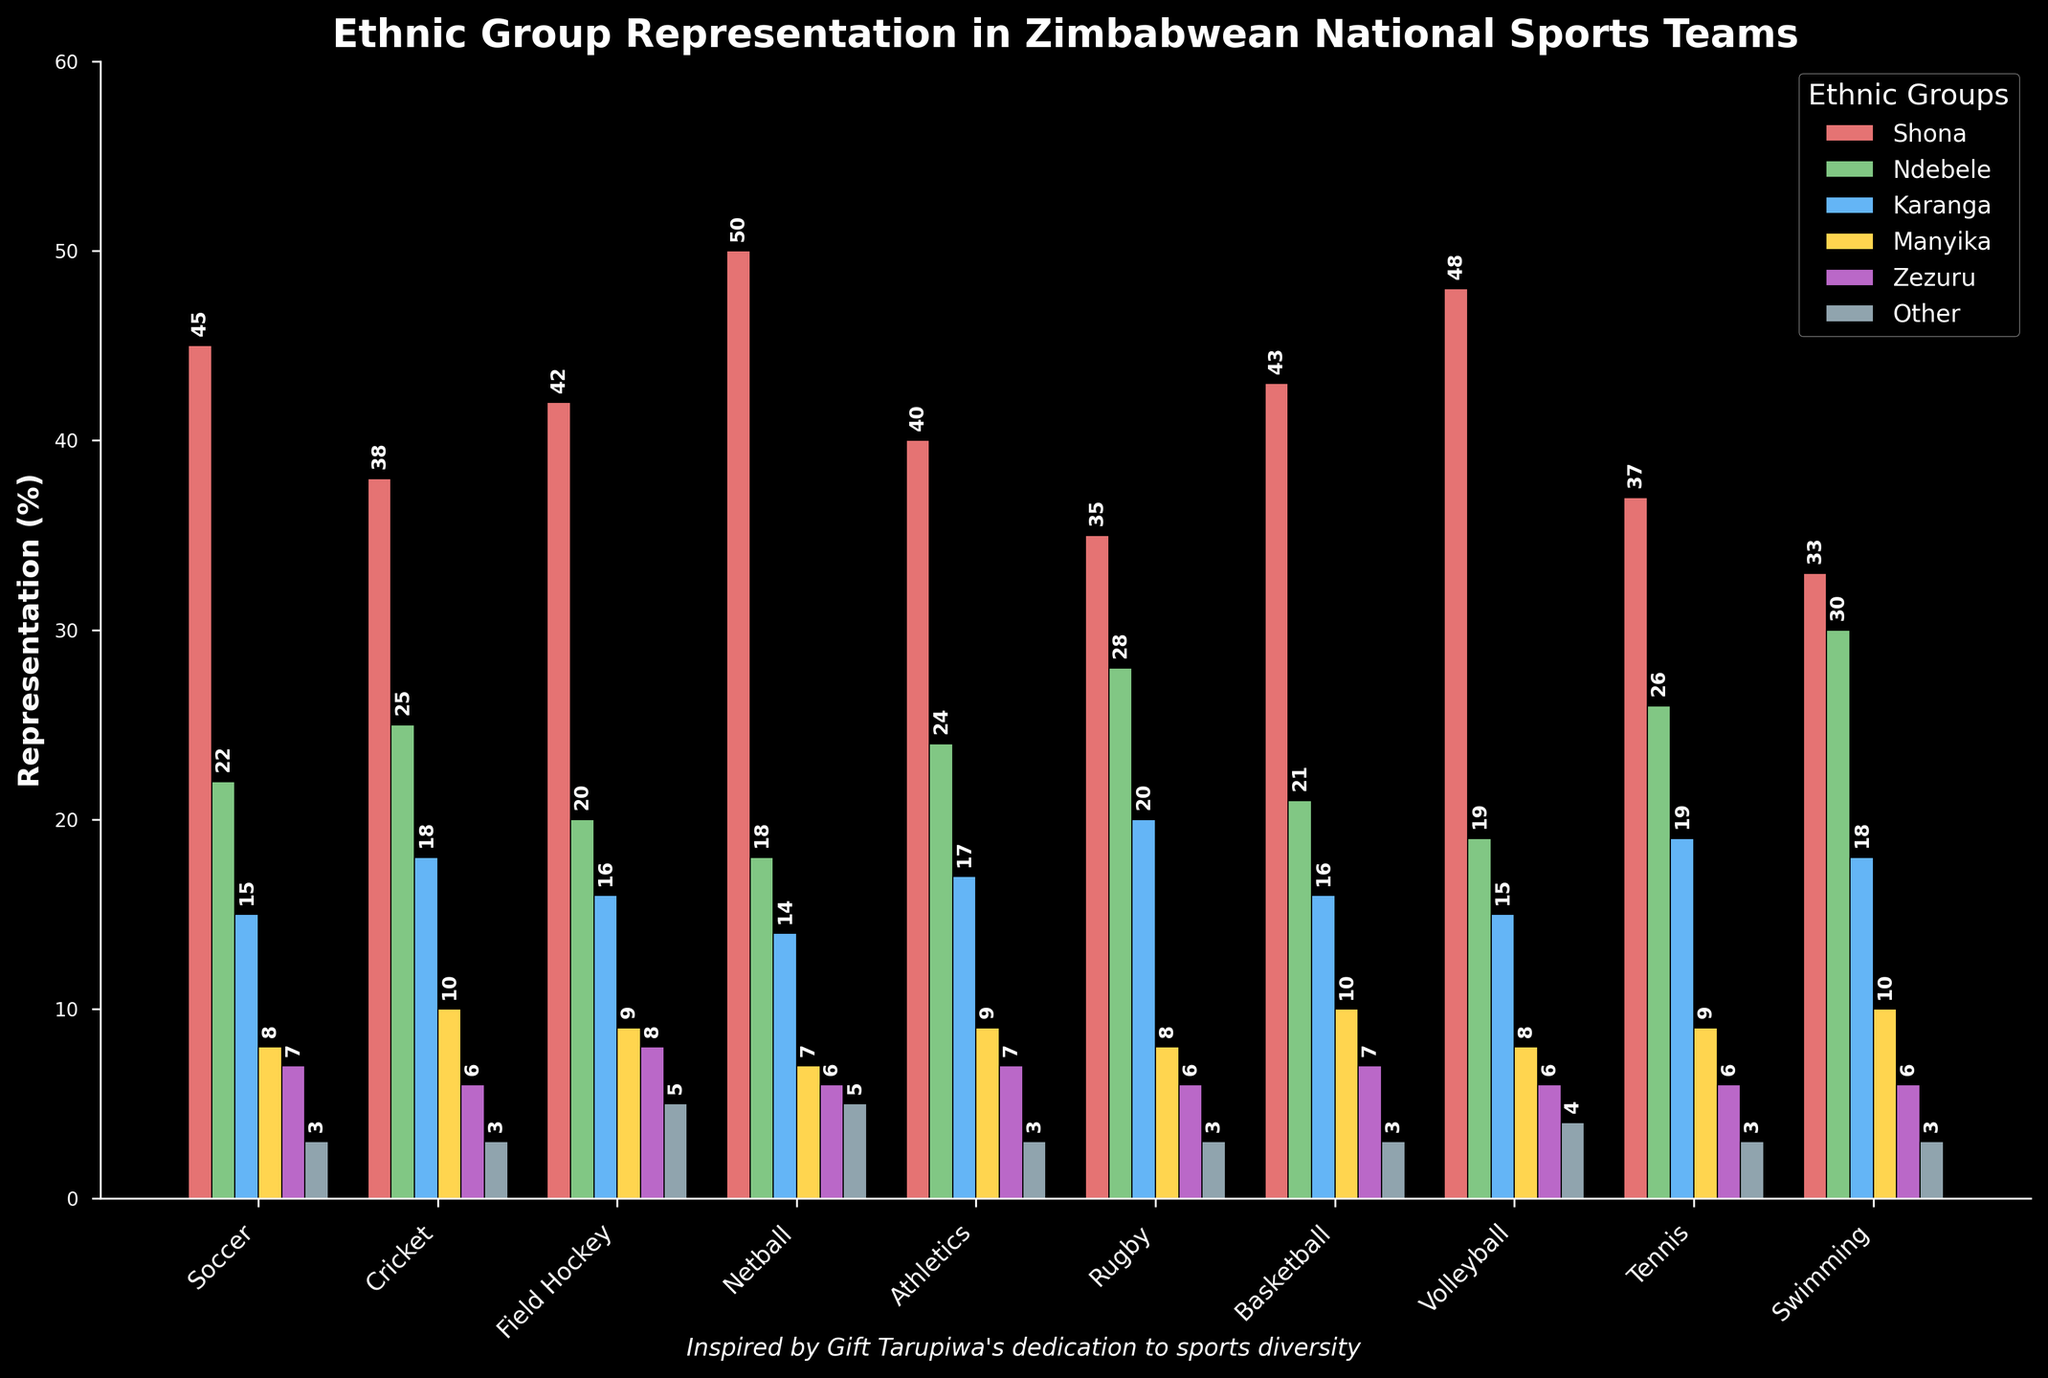Which ethnic group has the highest representation in Netball? Look at the bars for Netball and compare their heights. The tallest bar represents the Shona ethnic group.
Answer: Shona Which sport has the highest representation of the Ndebele ethnic group? Compare the height of the Ndebele bars across all sports. The tallest Ndebele bar is in Swimming.
Answer: Swimming What's the total representation percentage of the Manyika ethnic group across all sports? Sum up the Manyika values from all sports: 8+10+9+7+9+8+10+8+9+10 = 88
Answer: 88 How does Shona representation in Soccer compare to Cricket? Compare the height of the Shona bar in Soccer to that in Cricket. Soccer has 45% and Cricket has 38%.
Answer: Soccer has higher representation Which ethnic group has the least representation in Field Hockey? Look at the bars for Field Hockey and find the shortest bar. The shortest bar represents the "Other" ethnic group.
Answer: Other What's the average representation percentage of the Zezuru ethnic group in all sports? Sum up the Zezuru values and divide by the number of sports: (7+6+8+6+7+6+7+6+6+6)/10 = 6.5
Answer: 6.5 Compare the representation of Karanga and Manyika ethnic groups in Rugby. Compare the heights of Karanga and Manyika bars in Rugby. Karanga has 20% and Manyika has 8%.
Answer: Karanga is higher What’s the difference in representation percentage between Shona and Ndebele in Basketball? Find the difference between the Shona and Ndebele representation: 43-21 = 22
Answer: 22 Which sport has the most even distribution across all ethnic groups? Look for the sport where all bars are similar in height. Many bars in Rugby are relatively even compared to others.
Answer: Rugby What is the total representation of the 'Other' ethnic group across Soccer, Cricket, and Field Hockey? Sum the values of the Other ethnic group for those sports: 3+3+5 = 11
Answer: 11 